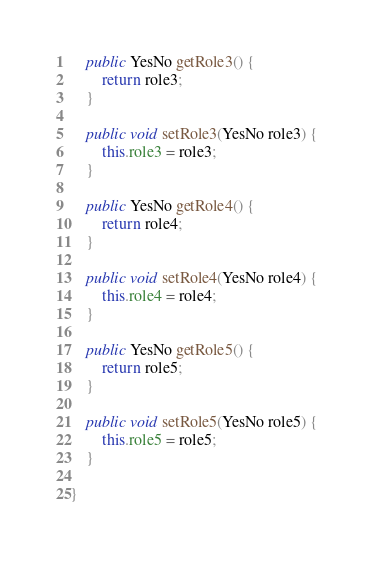Convert code to text. <code><loc_0><loc_0><loc_500><loc_500><_Java_>
    public YesNo getRole3() {
        return role3;
    }

    public void setRole3(YesNo role3) {
        this.role3 = role3;
    }

    public YesNo getRole4() {
        return role4;
    }

    public void setRole4(YesNo role4) {
        this.role4 = role4;
    }

    public YesNo getRole5() {
        return role5;
    }

    public void setRole5(YesNo role5) {
        this.role5 = role5;
    }

}
</code> 